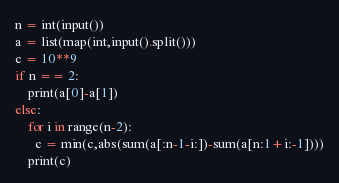Convert code to text. <code><loc_0><loc_0><loc_500><loc_500><_Python_>n = int(input())
a = list(map(int,input().split()))
c = 10**9
if n == 2:
    print(a[0]-a[1])
else:
    for i in range(n-2):
      c = min(c,abs(sum(a[:n-1-i:])-sum(a[n:1+i:-1])))
    print(c)</code> 